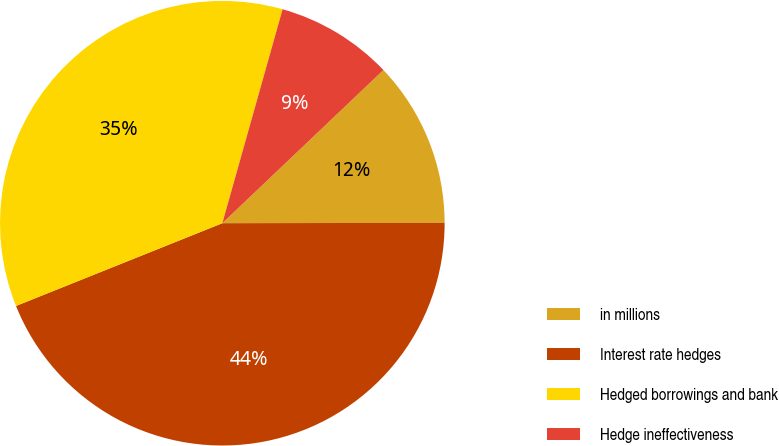<chart> <loc_0><loc_0><loc_500><loc_500><pie_chart><fcel>in millions<fcel>Interest rate hedges<fcel>Hedged borrowings and bank<fcel>Hedge ineffectiveness<nl><fcel>12.07%<fcel>43.96%<fcel>35.44%<fcel>8.53%<nl></chart> 